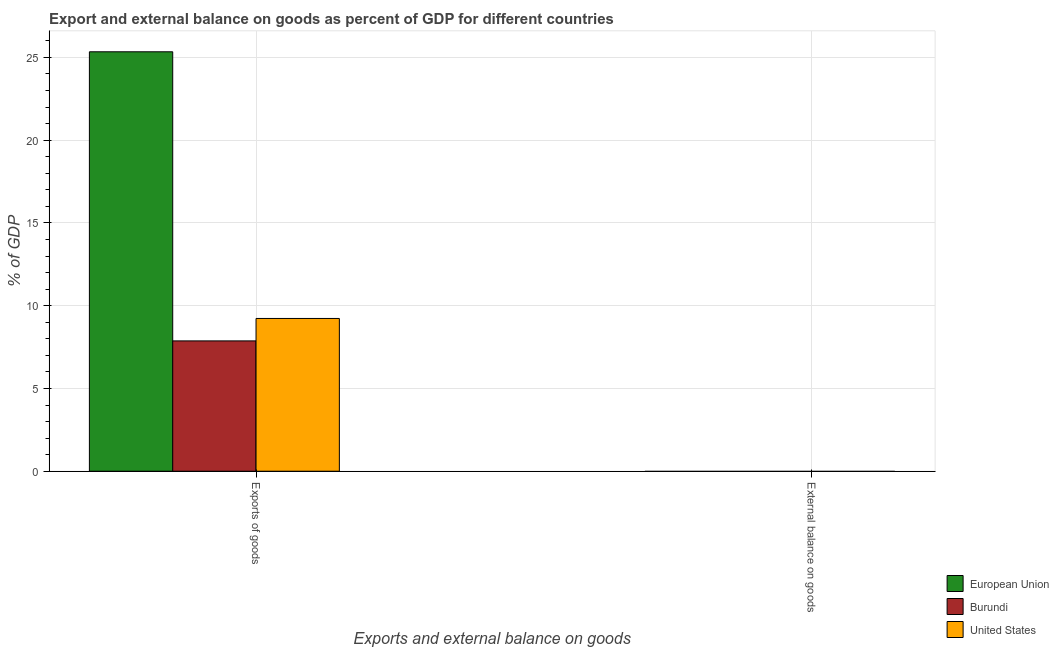Are the number of bars per tick equal to the number of legend labels?
Ensure brevity in your answer.  No. How many bars are there on the 2nd tick from the left?
Keep it short and to the point. 0. How many bars are there on the 1st tick from the right?
Offer a terse response. 0. What is the label of the 1st group of bars from the left?
Keep it short and to the point. Exports of goods. What is the external balance on goods as percentage of gdp in European Union?
Your answer should be very brief. 0. Across all countries, what is the maximum export of goods as percentage of gdp?
Provide a succinct answer. 25.34. Across all countries, what is the minimum export of goods as percentage of gdp?
Provide a short and direct response. 7.87. In which country was the export of goods as percentage of gdp maximum?
Your answer should be compact. European Union. What is the difference between the export of goods as percentage of gdp in United States and that in European Union?
Your answer should be compact. -16.11. What is the difference between the external balance on goods as percentage of gdp in European Union and the export of goods as percentage of gdp in United States?
Offer a very short reply. -9.23. What is the average external balance on goods as percentage of gdp per country?
Your answer should be very brief. 0. What is the ratio of the export of goods as percentage of gdp in United States to that in Burundi?
Your answer should be very brief. 1.17. Are all the bars in the graph horizontal?
Your answer should be compact. No. Does the graph contain any zero values?
Make the answer very short. Yes. Does the graph contain grids?
Ensure brevity in your answer.  Yes. How are the legend labels stacked?
Offer a very short reply. Vertical. What is the title of the graph?
Provide a short and direct response. Export and external balance on goods as percent of GDP for different countries. Does "Korea (Democratic)" appear as one of the legend labels in the graph?
Ensure brevity in your answer.  No. What is the label or title of the X-axis?
Provide a succinct answer. Exports and external balance on goods. What is the label or title of the Y-axis?
Your answer should be compact. % of GDP. What is the % of GDP in European Union in Exports of goods?
Offer a very short reply. 25.34. What is the % of GDP of Burundi in Exports of goods?
Provide a succinct answer. 7.87. What is the % of GDP in United States in Exports of goods?
Offer a terse response. 9.23. What is the % of GDP in European Union in External balance on goods?
Offer a terse response. 0. What is the % of GDP in United States in External balance on goods?
Provide a succinct answer. 0. Across all Exports and external balance on goods, what is the maximum % of GDP of European Union?
Your answer should be very brief. 25.34. Across all Exports and external balance on goods, what is the maximum % of GDP in Burundi?
Give a very brief answer. 7.87. Across all Exports and external balance on goods, what is the maximum % of GDP of United States?
Offer a very short reply. 9.23. Across all Exports and external balance on goods, what is the minimum % of GDP of Burundi?
Your answer should be compact. 0. Across all Exports and external balance on goods, what is the minimum % of GDP of United States?
Provide a succinct answer. 0. What is the total % of GDP of European Union in the graph?
Offer a very short reply. 25.34. What is the total % of GDP in Burundi in the graph?
Ensure brevity in your answer.  7.87. What is the total % of GDP of United States in the graph?
Make the answer very short. 9.23. What is the average % of GDP in European Union per Exports and external balance on goods?
Make the answer very short. 12.67. What is the average % of GDP of Burundi per Exports and external balance on goods?
Your answer should be very brief. 3.94. What is the average % of GDP in United States per Exports and external balance on goods?
Provide a succinct answer. 4.61. What is the difference between the % of GDP in European Union and % of GDP in Burundi in Exports of goods?
Offer a very short reply. 17.47. What is the difference between the % of GDP of European Union and % of GDP of United States in Exports of goods?
Offer a very short reply. 16.11. What is the difference between the % of GDP in Burundi and % of GDP in United States in Exports of goods?
Your response must be concise. -1.36. What is the difference between the highest and the lowest % of GDP in European Union?
Your answer should be very brief. 25.34. What is the difference between the highest and the lowest % of GDP in Burundi?
Your answer should be compact. 7.87. What is the difference between the highest and the lowest % of GDP in United States?
Provide a succinct answer. 9.23. 